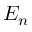Convert formula to latex. <formula><loc_0><loc_0><loc_500><loc_500>E _ { n }</formula> 